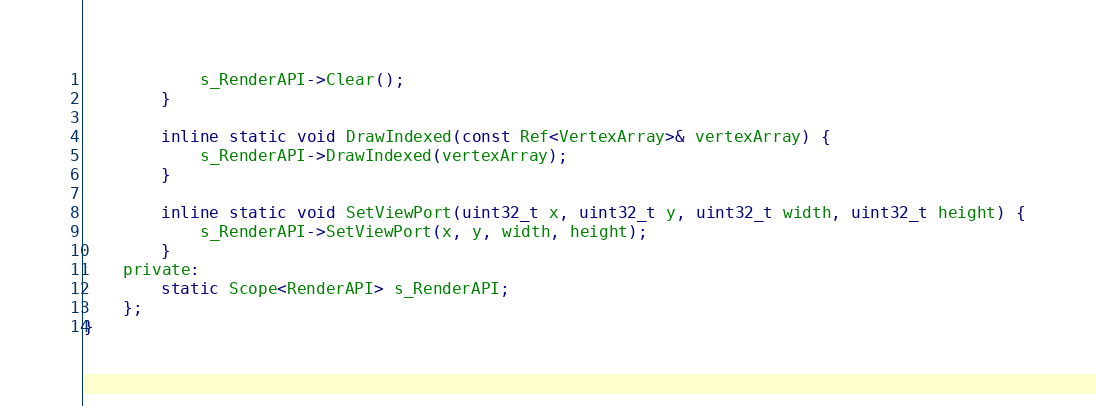Convert code to text. <code><loc_0><loc_0><loc_500><loc_500><_C_>			s_RenderAPI->Clear();
		}

		inline static void DrawIndexed(const Ref<VertexArray>& vertexArray) {
			s_RenderAPI->DrawIndexed(vertexArray);
		}
		
		inline static void SetViewPort(uint32_t x, uint32_t y, uint32_t width, uint32_t height) {
			s_RenderAPI->SetViewPort(x, y, width, height);
		}
	private:
		static Scope<RenderAPI> s_RenderAPI;
	};
}


</code> 